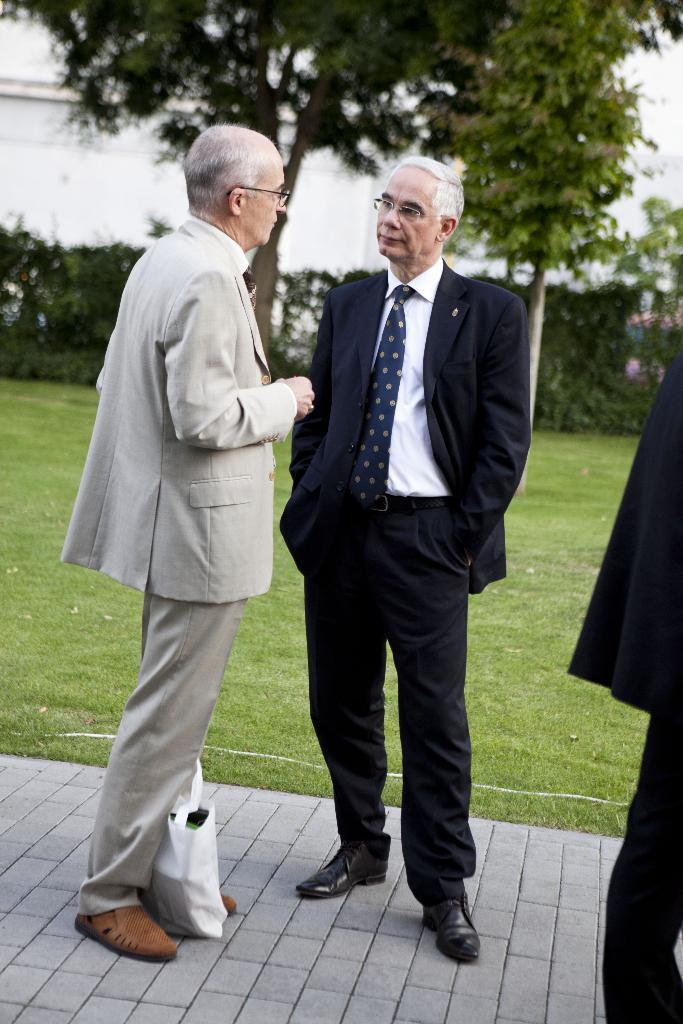How many men are in the image? There are two men in the image. What are the men wearing? The men are wearing suits and ties. What is at the bottom of the image? There is a floor at the bottom of the image. What can be seen in the background of the image? There is green grass and trees in the background of the image. What is located on the left side of the image? There is a small building on the left side of the image. What type of cracker is being used to hit the sticks together in the image? There is no cracker or sticks present in the image. What show are the men attending in the image? There is no indication of a show or event in the image. 